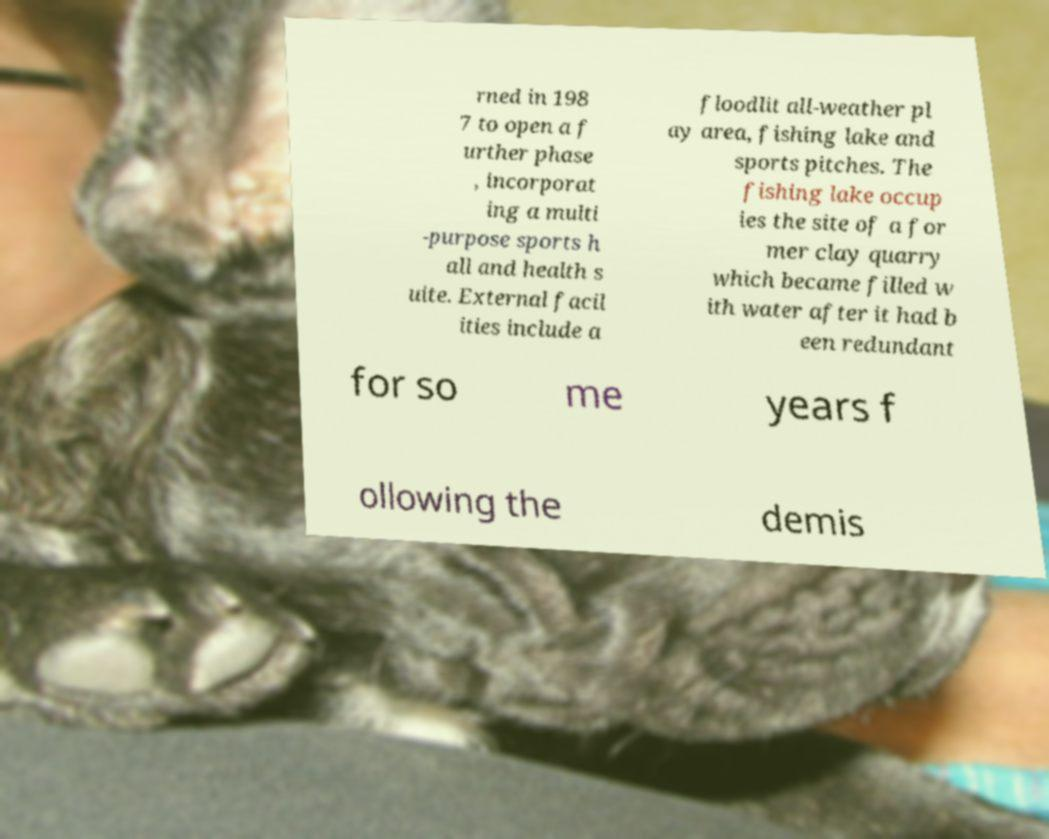I need the written content from this picture converted into text. Can you do that? rned in 198 7 to open a f urther phase , incorporat ing a multi -purpose sports h all and health s uite. External facil ities include a floodlit all-weather pl ay area, fishing lake and sports pitches. The fishing lake occup ies the site of a for mer clay quarry which became filled w ith water after it had b een redundant for so me years f ollowing the demis 